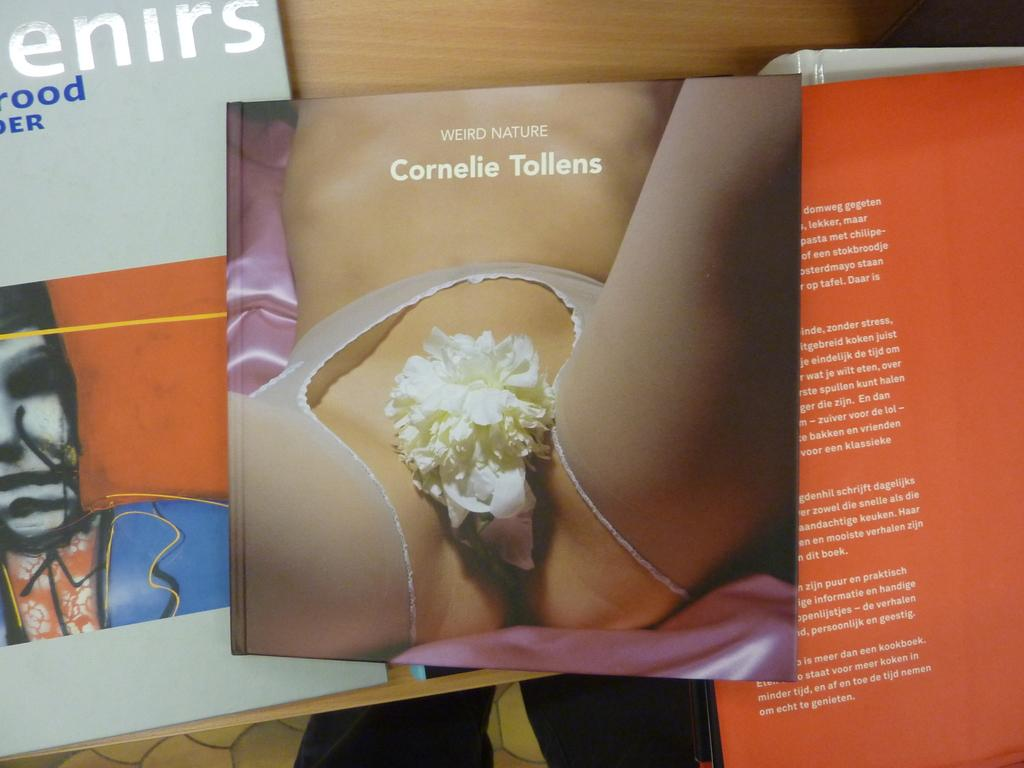<image>
Provide a brief description of the given image. The book sitting in the middle is called weird Nature. 